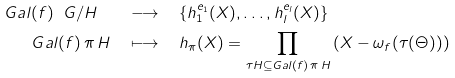Convert formula to latex. <formula><loc_0><loc_0><loc_500><loc_500>G a l ( f ) \ G / H \quad & \longrightarrow \quad \{ h _ { 1 } ^ { e _ { 1 } } ( X ) , \dots , h _ { l } ^ { e _ { l } } ( X ) \} \\ G a l ( f ) \, \pi \, H \quad & \longmapsto \quad h _ { \pi } ( X ) = \prod _ { \tau H \subseteq G a l ( f ) \, \pi \, H } \left ( X - \omega _ { f } ( \tau ( \Theta ) ) \right )</formula> 